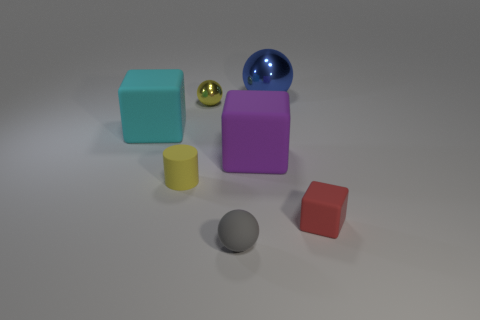There is a tiny rubber object behind the small red rubber block; what shape is it? cylinder 